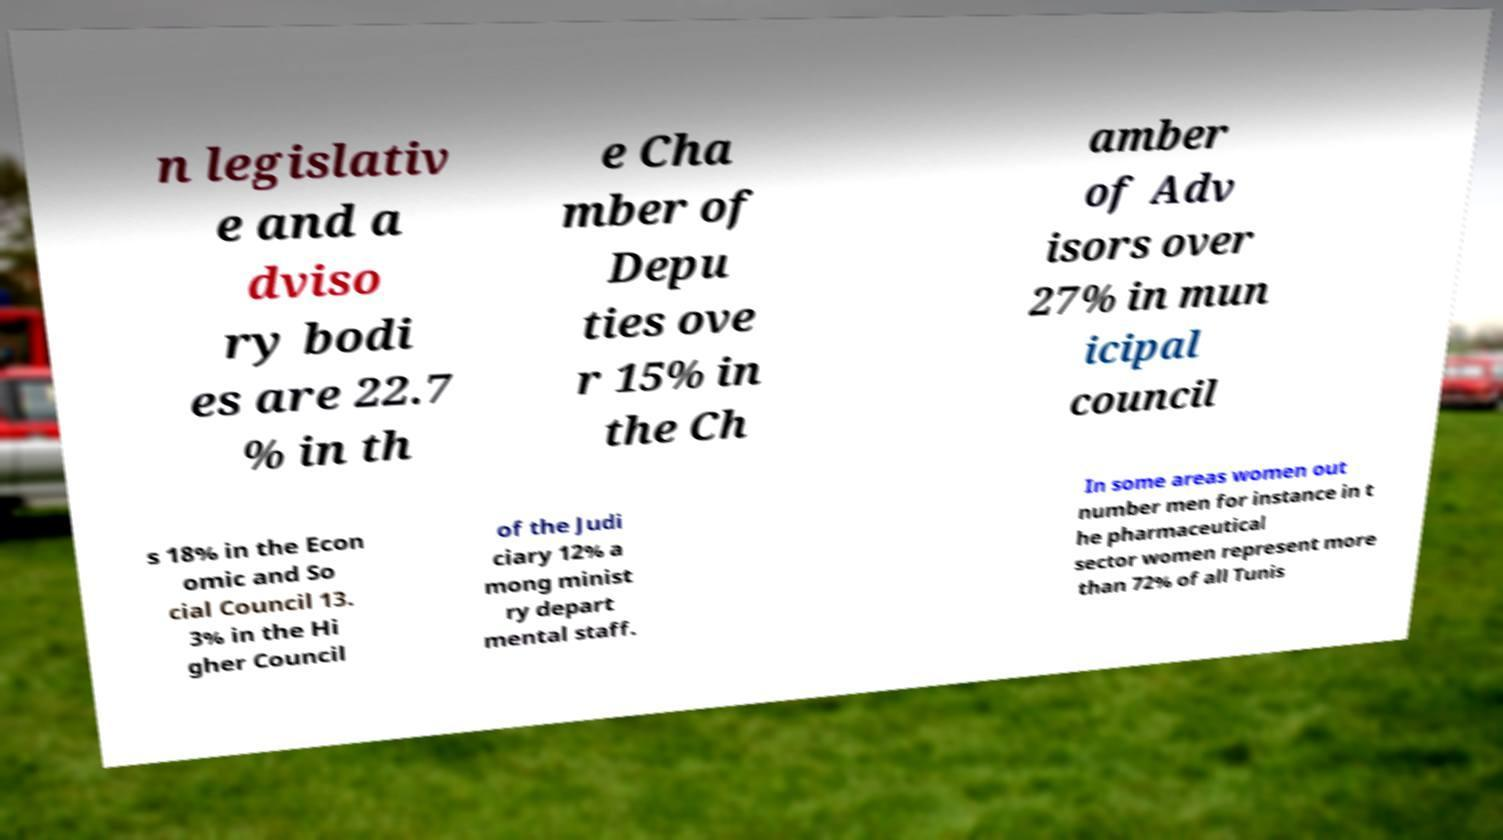Can you accurately transcribe the text from the provided image for me? n legislativ e and a dviso ry bodi es are 22.7 % in th e Cha mber of Depu ties ove r 15% in the Ch amber of Adv isors over 27% in mun icipal council s 18% in the Econ omic and So cial Council 13. 3% in the Hi gher Council of the Judi ciary 12% a mong minist ry depart mental staff. In some areas women out number men for instance in t he pharmaceutical sector women represent more than 72% of all Tunis 